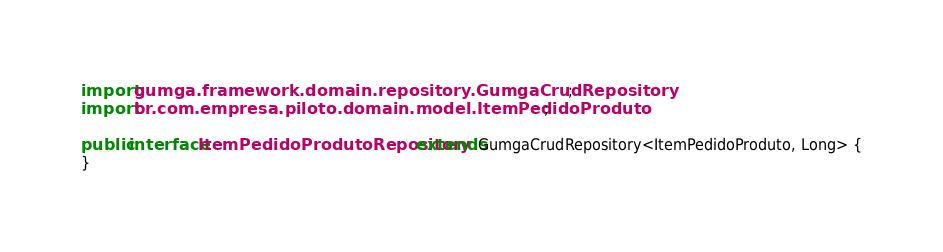Convert code to text. <code><loc_0><loc_0><loc_500><loc_500><_Java_>
import gumga.framework.domain.repository.GumgaCrudRepository;
import br.com.empresa.piloto.domain.model.ItemPedidoProduto;

public interface ItemPedidoProdutoRepository extends GumgaCrudRepository<ItemPedidoProduto, Long> {
}</code> 